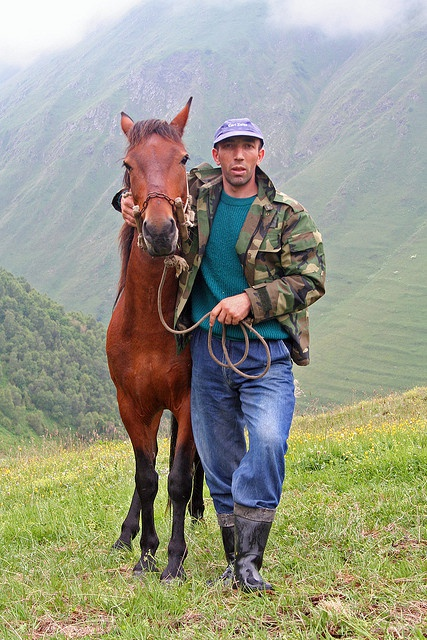Describe the objects in this image and their specific colors. I can see people in white, black, gray, blue, and navy tones and horse in white, maroon, black, brown, and gray tones in this image. 